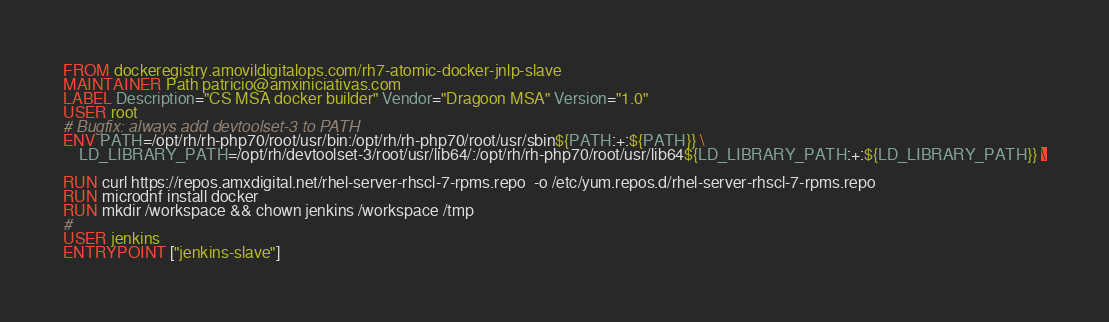<code> <loc_0><loc_0><loc_500><loc_500><_Dockerfile_>FROM dockeregistry.amovildigitalops.com/rh7-atomic-docker-jnlp-slave
MAINTAINER Path patricio@amxiniciativas.com
LABEL Description="CS MSA docker builder" Vendor="Dragoon MSA" Version="1.0"
USER root
# Bugfix: always add devtoolset-3 to PATH
ENV PATH=/opt/rh/rh-php70/root/usr/bin:/opt/rh/rh-php70/root/usr/sbin${PATH:+:${PATH}} \
    LD_LIBRARY_PATH=/opt/rh/devtoolset-3/root/usr/lib64/:/opt/rh/rh-php70/root/usr/lib64${LD_LIBRARY_PATH:+:${LD_LIBRARY_PATH}} \

RUN curl https://repos.amxdigital.net/rhel-server-rhscl-7-rpms.repo  -o /etc/yum.repos.d/rhel-server-rhscl-7-rpms.repo
RUN microdnf install docker
RUN mkdir /workspace && chown jenkins /workspace /tmp
#
USER jenkins
ENTRYPOINT ["jenkins-slave"]
</code> 